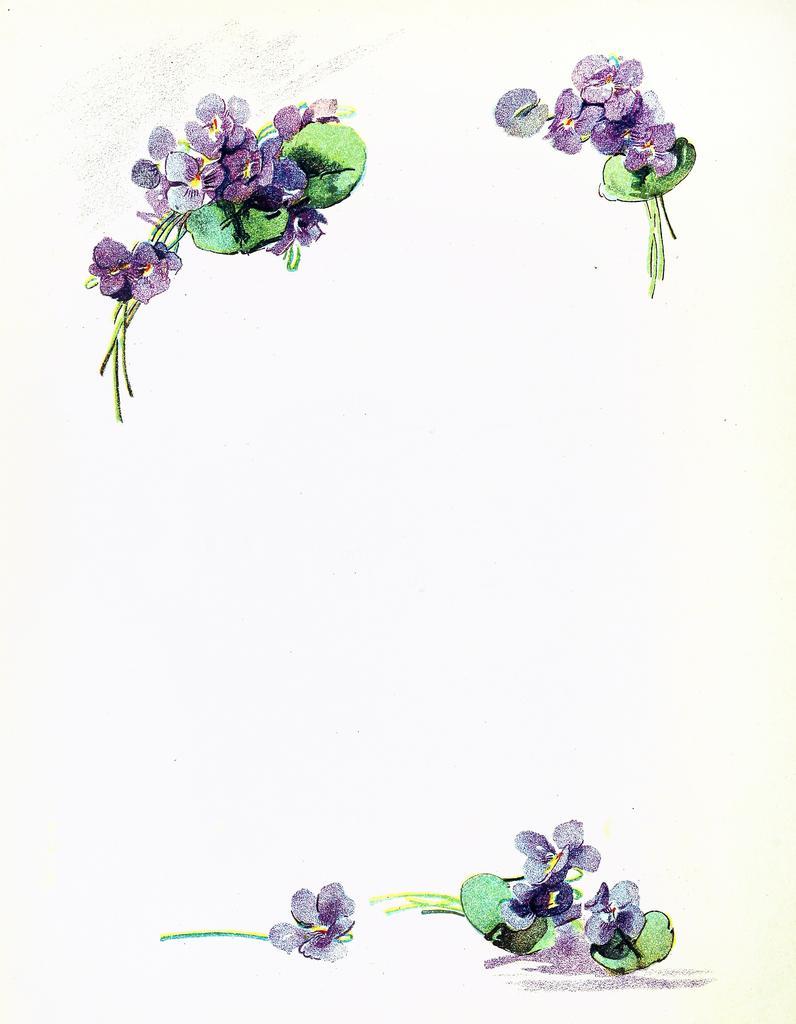In one or two sentences, can you explain what this image depicts? In this picture it looks like a paper, we can see printed flowers and leaves on the paper. 